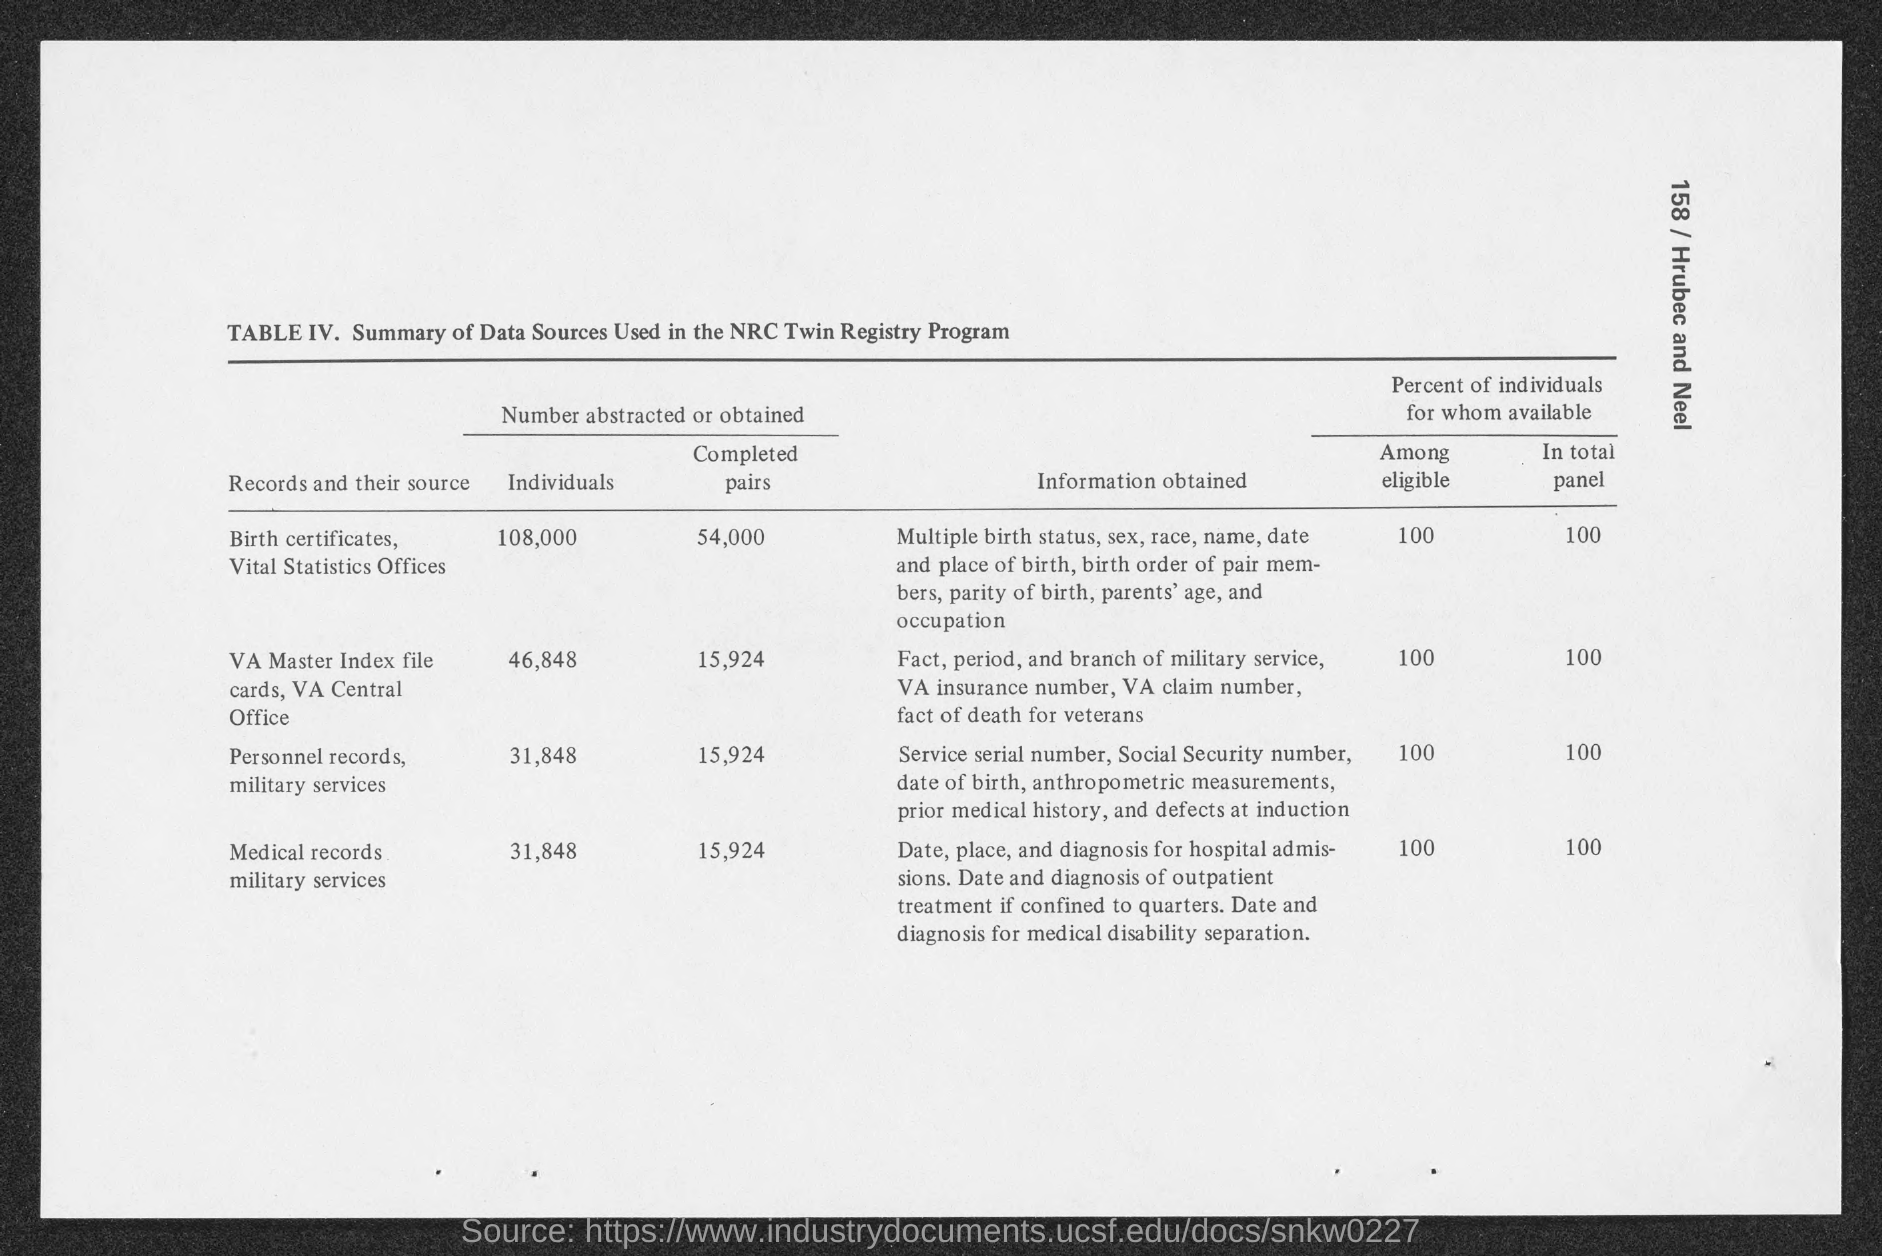What is the title of table IV?
Provide a short and direct response. Summary of Data Sources Used in the NRC Twin Registry Program. From which records were maximum pairs completed?
Your response must be concise. Birth certificates, Vital Statistics Offices. How many individuals were obtained from Medical records military services?
Offer a very short reply. 31,848. 